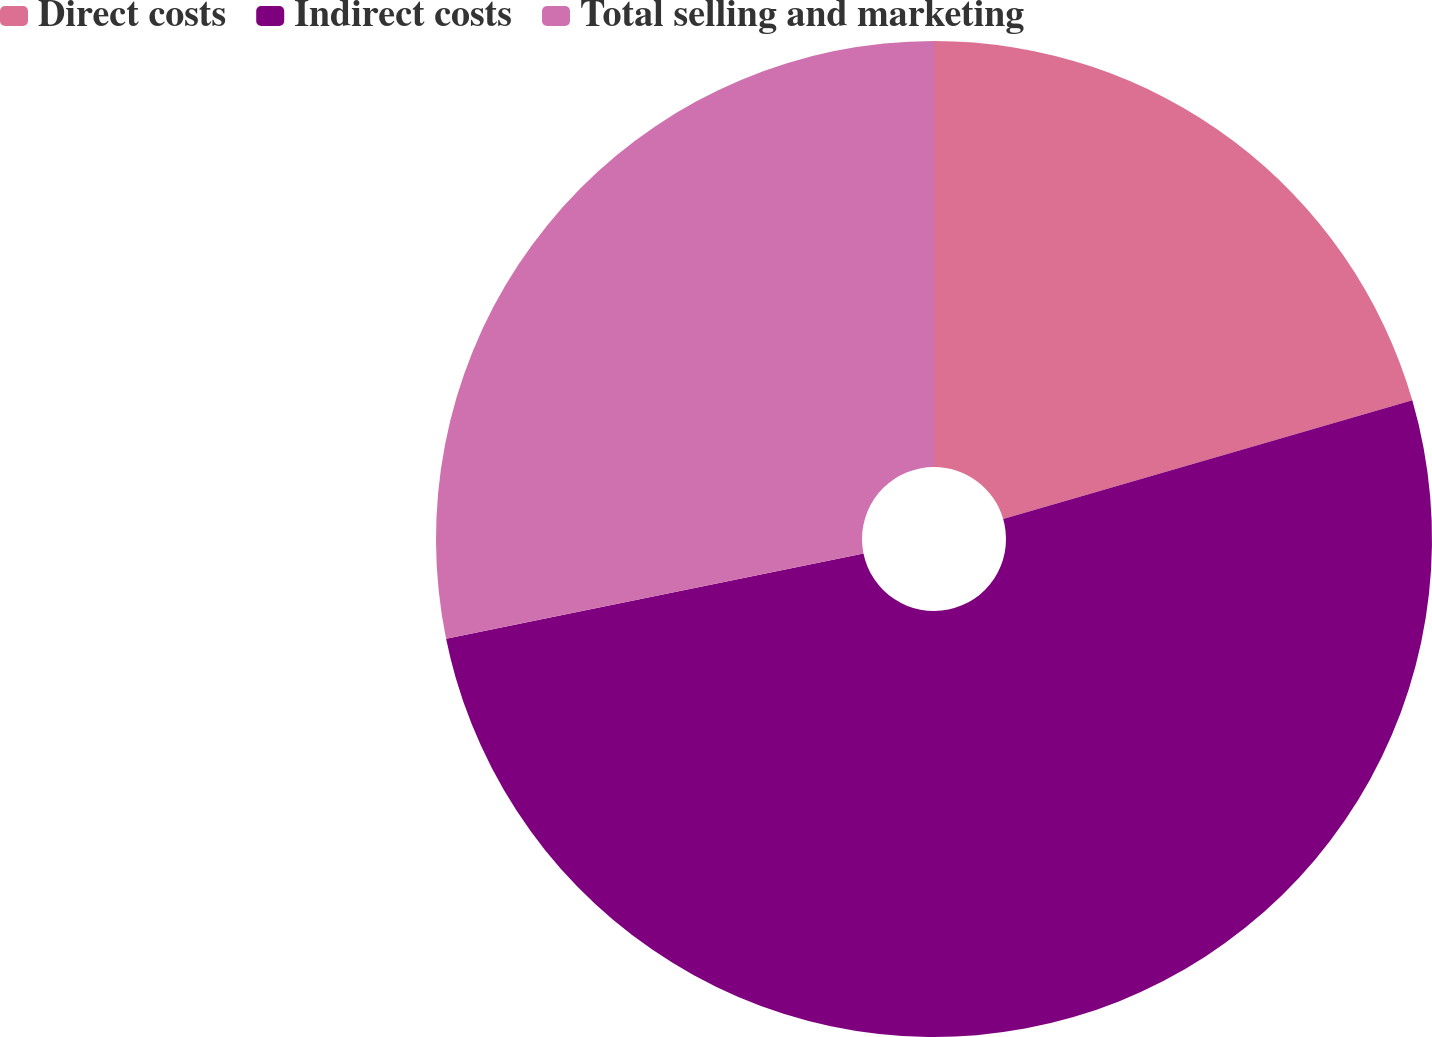Convert chart to OTSL. <chart><loc_0><loc_0><loc_500><loc_500><pie_chart><fcel>Direct costs<fcel>Indirect costs<fcel>Total selling and marketing<nl><fcel>20.51%<fcel>51.28%<fcel>28.21%<nl></chart> 